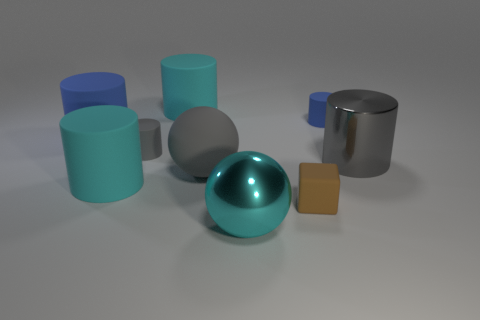Subtract all gray cylinders. How many cylinders are left? 4 Subtract all blue cylinders. How many cylinders are left? 4 Subtract all yellow cylinders. Subtract all cyan spheres. How many cylinders are left? 6 Add 1 cyan spheres. How many objects exist? 10 Subtract all cylinders. How many objects are left? 3 Add 8 big spheres. How many big spheres exist? 10 Subtract 0 red blocks. How many objects are left? 9 Subtract all small gray cylinders. Subtract all large brown balls. How many objects are left? 8 Add 4 big gray shiny things. How many big gray shiny things are left? 5 